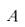Convert formula to latex. <formula><loc_0><loc_0><loc_500><loc_500>A</formula> 